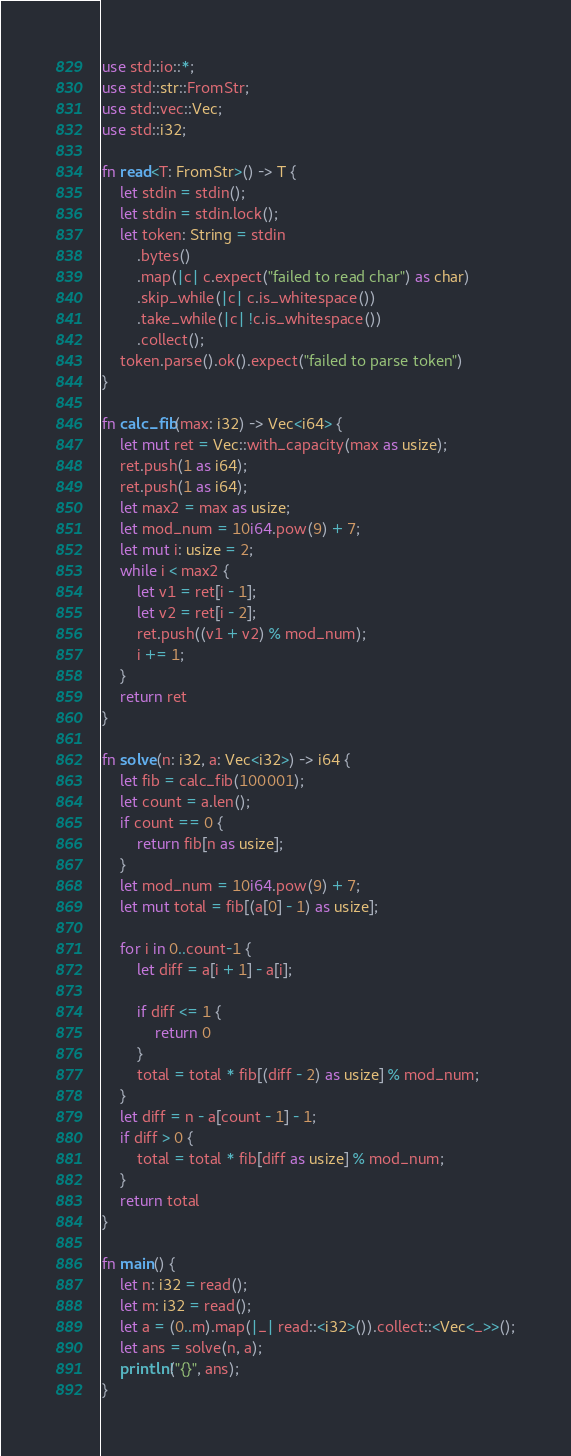<code> <loc_0><loc_0><loc_500><loc_500><_Rust_>use std::io::*;
use std::str::FromStr;
use std::vec::Vec;
use std::i32;

fn read<T: FromStr>() -> T {
    let stdin = stdin();
    let stdin = stdin.lock();
    let token: String = stdin
        .bytes()
        .map(|c| c.expect("failed to read char") as char) 
        .skip_while(|c| c.is_whitespace())
        .take_while(|c| !c.is_whitespace())
        .collect();
    token.parse().ok().expect("failed to parse token")
}

fn calc_fib(max: i32) -> Vec<i64> {
    let mut ret = Vec::with_capacity(max as usize);
    ret.push(1 as i64);
    ret.push(1 as i64);
    let max2 = max as usize;
    let mod_num = 10i64.pow(9) + 7;
    let mut i: usize = 2;
    while i < max2 {
        let v1 = ret[i - 1];
        let v2 = ret[i - 2];
        ret.push((v1 + v2) % mod_num);
        i += 1;
    }
    return ret
}

fn solve(n: i32, a: Vec<i32>) -> i64 {
    let fib = calc_fib(100001);
    let count = a.len();
    if count == 0 {
        return fib[n as usize];
    }
    let mod_num = 10i64.pow(9) + 7;
    let mut total = fib[(a[0] - 1) as usize];

    for i in 0..count-1 {
        let diff = a[i + 1] - a[i];

        if diff <= 1 {
            return 0
        }
        total = total * fib[(diff - 2) as usize] % mod_num;
    }
    let diff = n - a[count - 1] - 1;
    if diff > 0 {
        total = total * fib[diff as usize] % mod_num;
    }
    return total
}

fn main() {
    let n: i32 = read();
    let m: i32 = read();
    let a = (0..m).map(|_| read::<i32>()).collect::<Vec<_>>();
    let ans = solve(n, a);
    println!("{}", ans);
}
</code> 